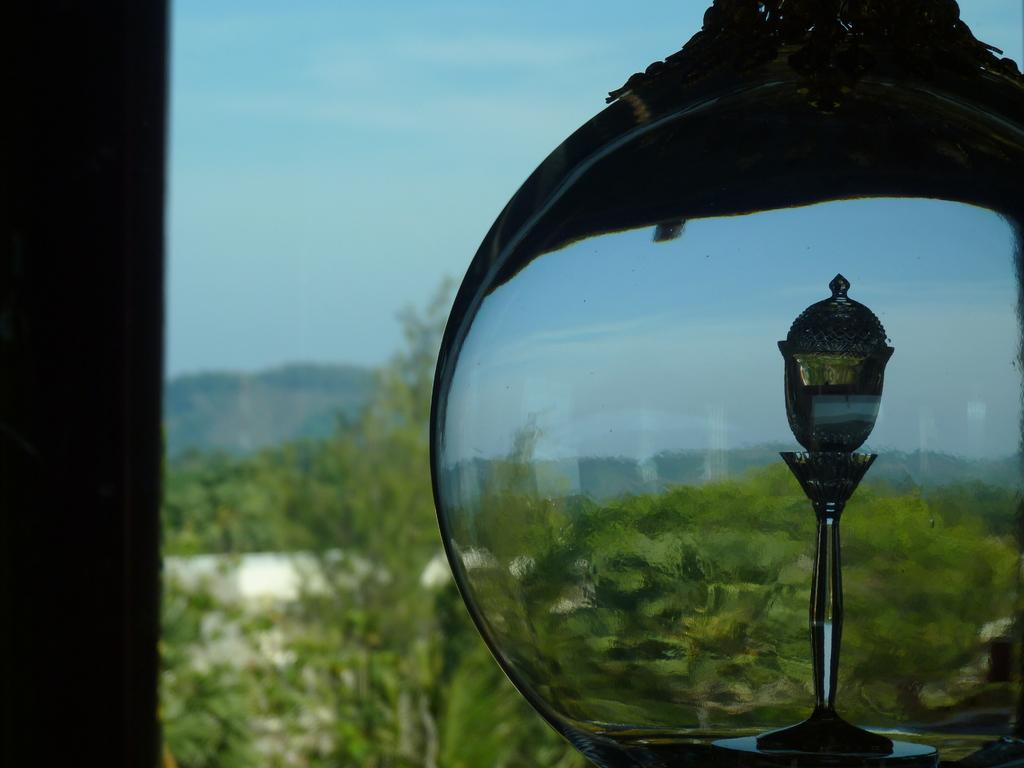What type of object is made of glass in the image? There is a glass object in the image, but its specific type is not mentioned. What kind of natural environment is visible in the image? There is greenery visible in the image, which suggests a natural setting. What is visible in the sky in the image? The sky is visible in the image, but no specific details about the sky are provided. What is located on the left side of the image? There appears to be a pole on the left side of the image. Can you tell me how many memories are stored in the glass object in the image? There is no mention of memories being stored in the glass object in the image, as it is not a device capable of storing memories. Is there a pocket visible in the image? There is no mention of a pocket in the image, so it cannot be confirmed or denied. 